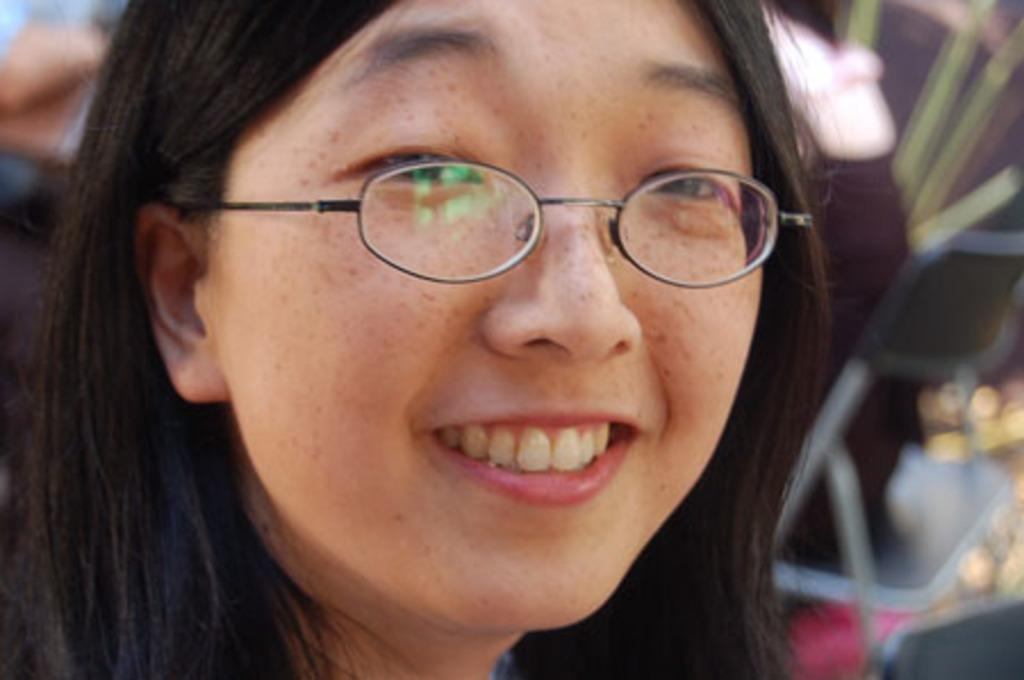Who is the main subject in the image? There is a woman in the image. What is the woman wearing on her face? The woman is wearing spectacles. Can you describe the background of the image? The background of the image is blurred. What type of oatmeal is the woman eating in the image? There is no oatmeal present in the image. What muscle is the woman exercising in the image? There is no exercise or muscle activity depicted in the image. 